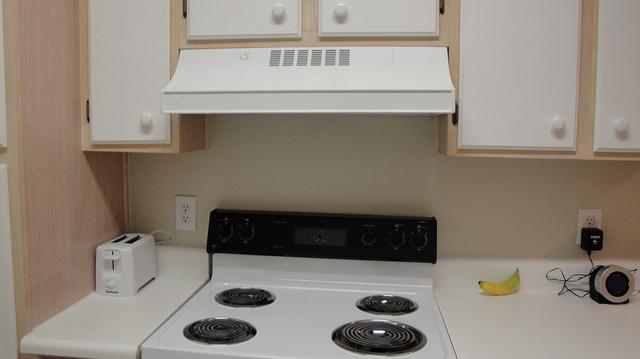Where is this?
Concise answer only. Kitchen. Is this a washroom?
Keep it brief. No. Is the stove gas or electric?
Short answer required. Electric. Is the kitchen clean?
Short answer required. Yes. What might be behind the small door in the upper right?
Keep it brief. Dishes. Is there any food in the room?
Answer briefly. Yes. How many burners are on the stove?
Short answer required. 4. 